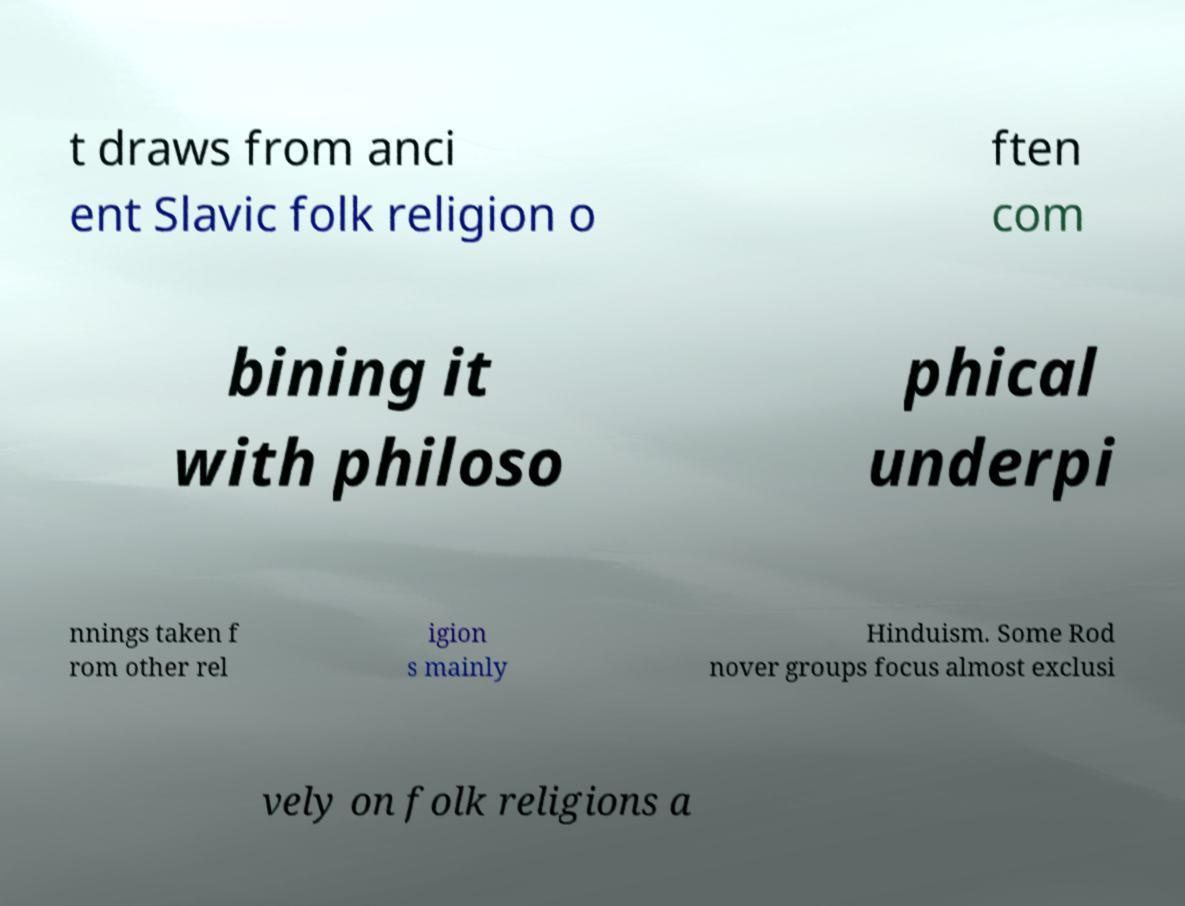I need the written content from this picture converted into text. Can you do that? t draws from anci ent Slavic folk religion o ften com bining it with philoso phical underpi nnings taken f rom other rel igion s mainly Hinduism. Some Rod nover groups focus almost exclusi vely on folk religions a 